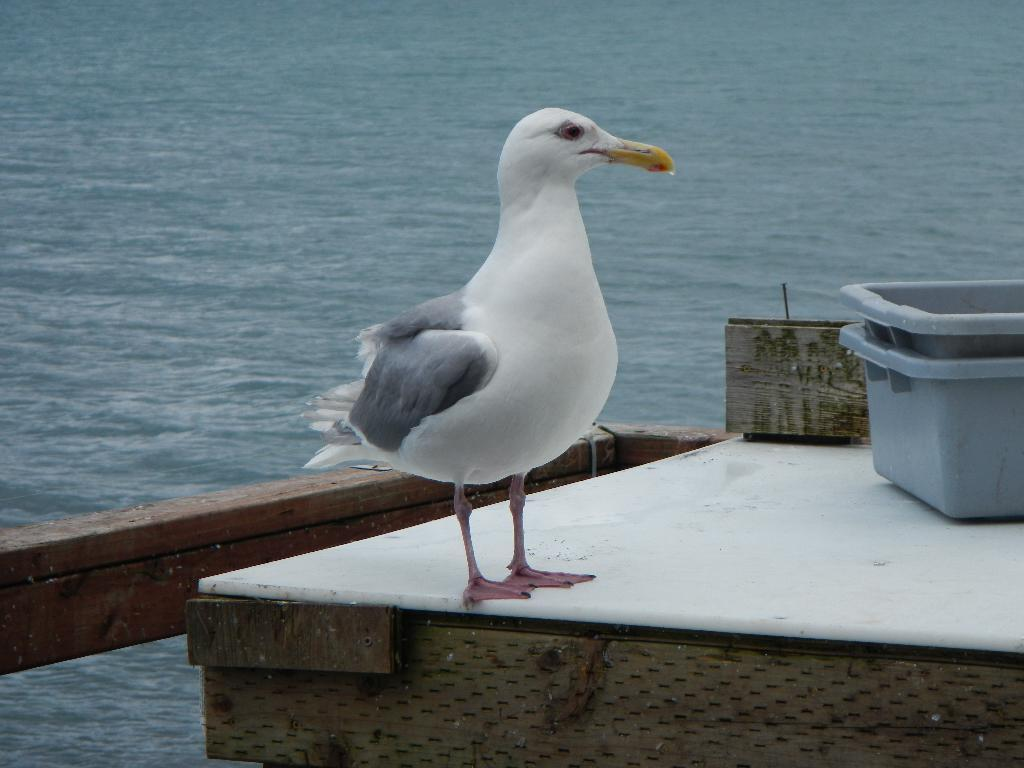What type of animal is in the picture? There is a bird in the picture. Can you describe the bird's beak? The bird has a long yellow beak. Where is the grey color box located in the picture? The box is placed on the right side. What can be seen in the background of the picture? There is an ocean in the background of the picture. What type of bread can be seen in the picture? There is no bread present in the picture. How many things are floating in the ocean in the background? The image does not provide information about the number of things floating in the ocean in the background. 